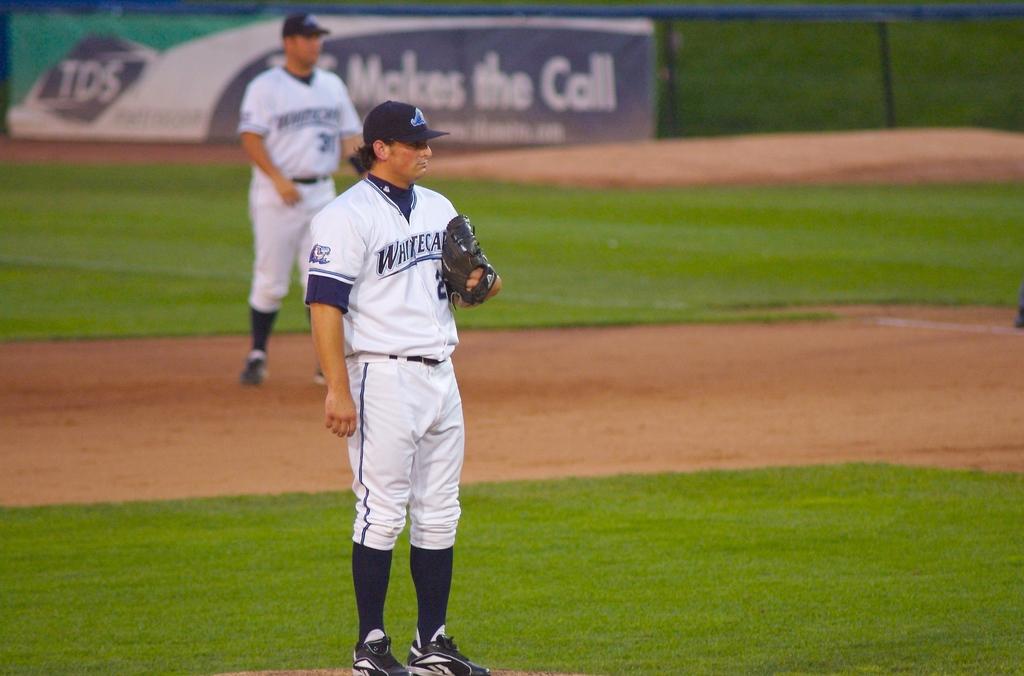What brand "makes the call?"?
Make the answer very short. Tds. 